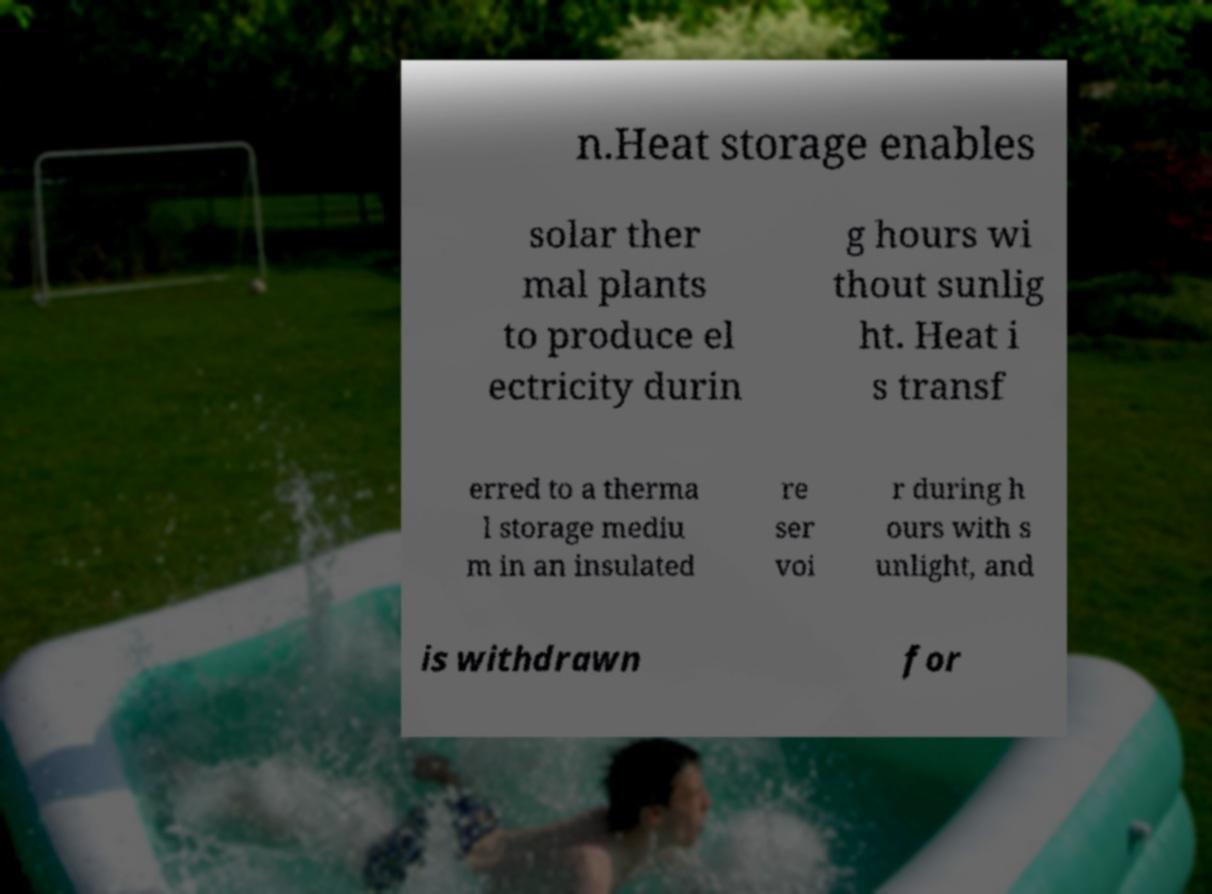Can you read and provide the text displayed in the image?This photo seems to have some interesting text. Can you extract and type it out for me? n.Heat storage enables solar ther mal plants to produce el ectricity durin g hours wi thout sunlig ht. Heat i s transf erred to a therma l storage mediu m in an insulated re ser voi r during h ours with s unlight, and is withdrawn for 